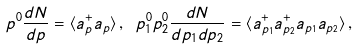<formula> <loc_0><loc_0><loc_500><loc_500>p ^ { 0 } \frac { d N } { d { p } } = \langle a _ { p } ^ { + } a _ { p } \rangle \, , \ p _ { 1 } ^ { 0 } p _ { 2 } ^ { 0 } \frac { d N } { d { p { \tt _ { 1 } } } d { p } { \tt _ { 2 } } } = \langle a _ { p _ { 1 } } ^ { + } a _ { p _ { 2 } } ^ { + } a _ { p _ { 1 } } a _ { p _ { 2 } } \rangle \, ,</formula> 